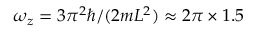Convert formula to latex. <formula><loc_0><loc_0><loc_500><loc_500>\omega _ { z } = 3 \pi ^ { 2 } \hbar { / } ( 2 m L ^ { 2 } ) \approx 2 \pi \times 1 . 5</formula> 